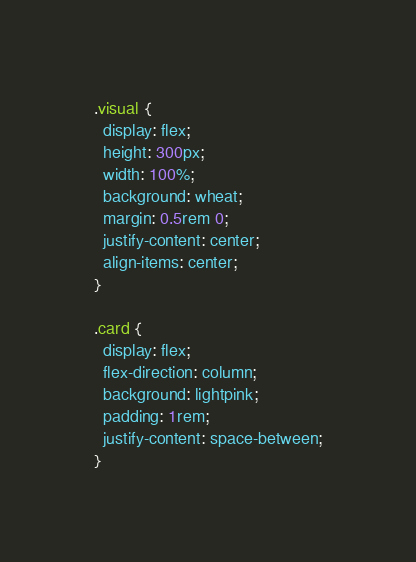<code> <loc_0><loc_0><loc_500><loc_500><_CSS_>
.visual {
  display: flex;
  height: 300px;
  width: 100%;
  background: wheat;
  margin: 0.5rem 0;
  justify-content: center;
  align-items: center;
}

.card {
  display: flex;
  flex-direction: column;
  background: lightpink;
  padding: 1rem;
  justify-content: space-between;
}
</code> 